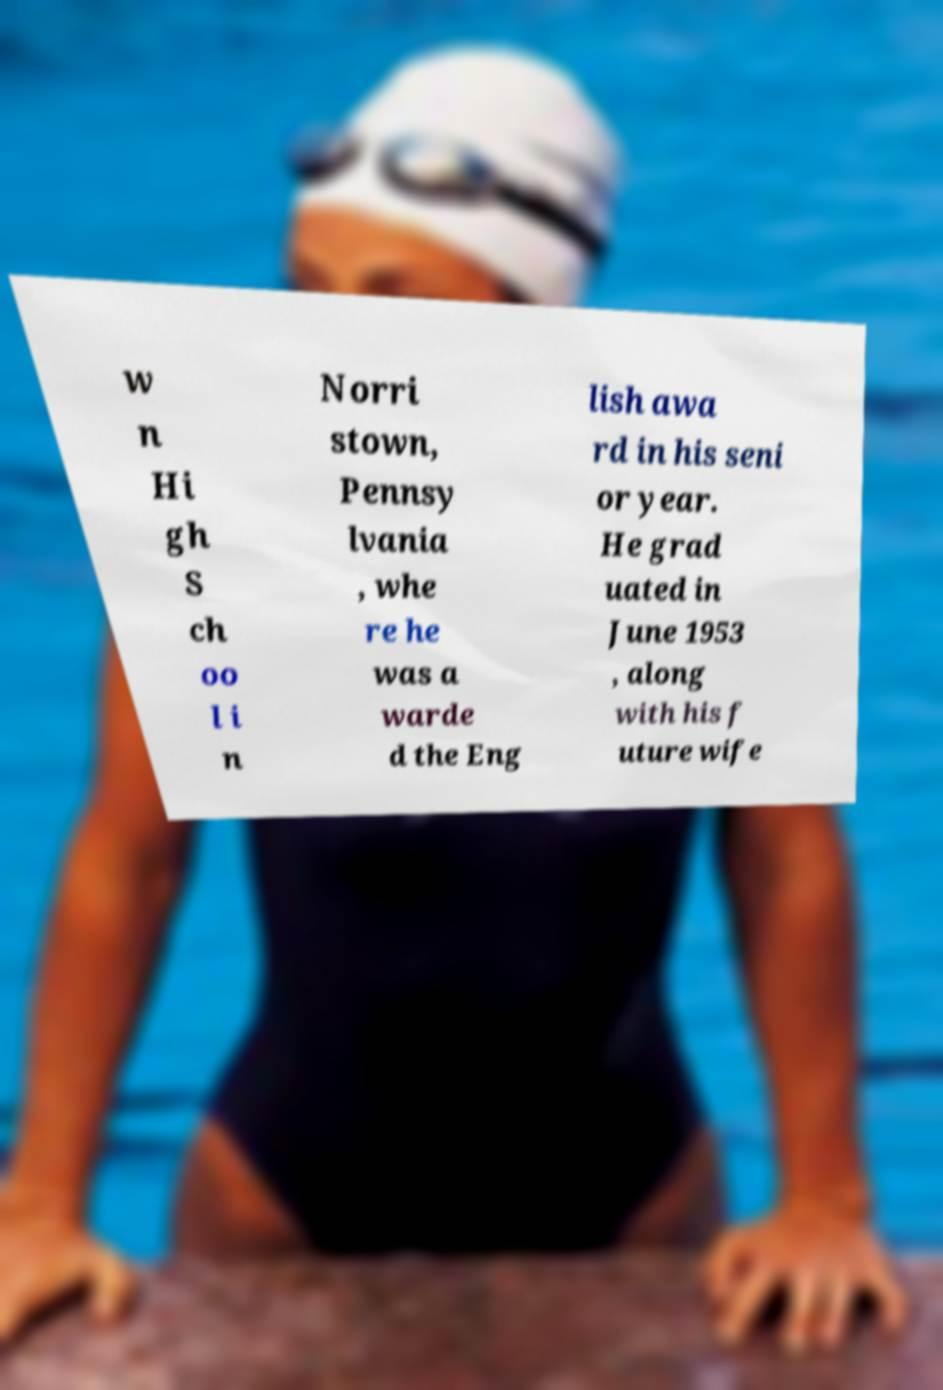Please identify and transcribe the text found in this image. w n Hi gh S ch oo l i n Norri stown, Pennsy lvania , whe re he was a warde d the Eng lish awa rd in his seni or year. He grad uated in June 1953 , along with his f uture wife 